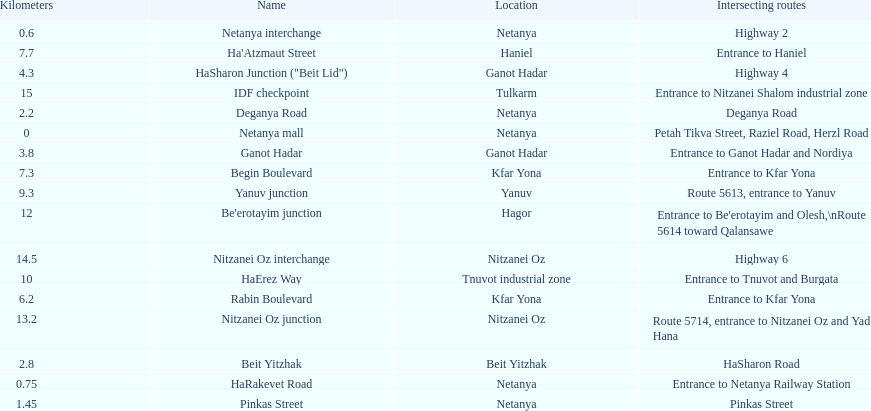Which location comes after kfar yona? Haniel. 